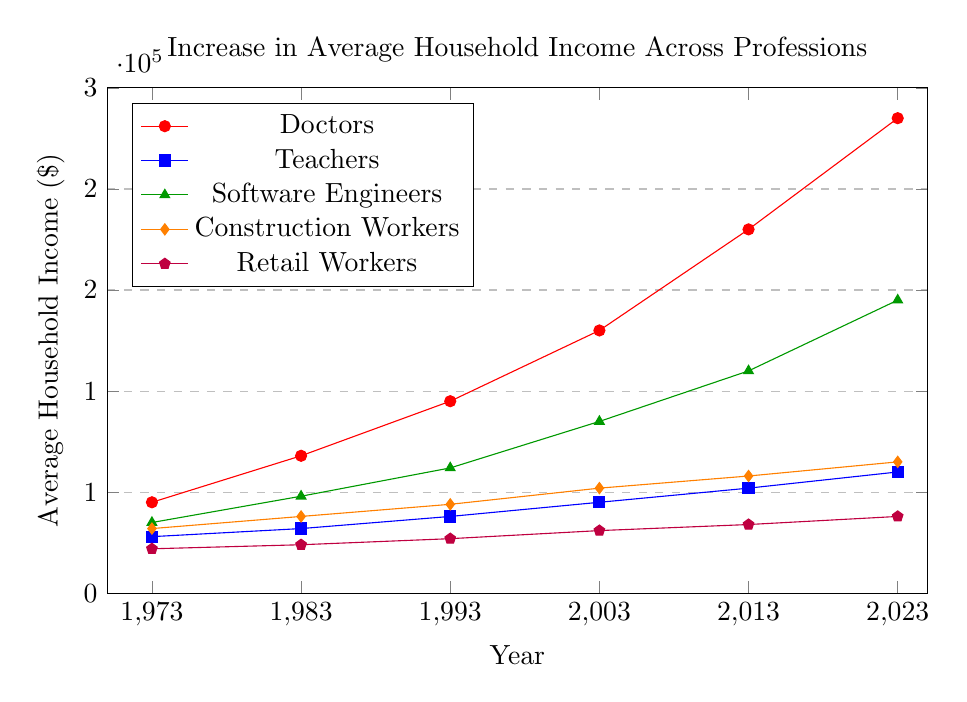What profession had the highest average household income in 2023? Look at the data points corresponding to the year 2023. The line representing Doctors has the highest value at $235,000.
Answer: Doctors What is the gap in average household income between Software Engineers and Retail Workers in 2023? Compare the income for Software Engineers ($145,000) and Retail Workers ($38,000) in 2023. Subtract the Retail Workers' income from Software Engineers' income: 145,000 - 38,000 = $107,000.
Answer: $107,000 Which profession showed the smallest increase in average household income from 1973 to 2023? Calculate the increase for each profession by subtracting the 1973 income from the 2023 income: Doctors (235,000 - 45,000 = 190,000), Teachers (60,000 - 28,000 = 32,000), Software Engineers (145,000 - 35,000 = 110,000), Construction Workers (65,000 - 32,000 = 33,000), Retail Workers (38,000 - 22,000 = 16,000). Retail Workers have the smallest increase of $16,000.
Answer: Retail Workers How much more did Doctors earn compared to Teachers in 1993? Check the 1993 income for Doctors ($95,000) and Teachers ($38,000). Subtract Teachers' income from Doctors' income: 95,000 - 38,000 = $57,000.
Answer: $57,000 Which two professions had the closest average household incomes in 2013? Compare the incomes for each profession in 2013: Doctors ($180,000), Teachers ($52,000), Software Engineers ($110,000), Construction Workers ($58,000), Retail Workers ($34,000). Construction Workers and Teachers have the closest values: 58,000 - 52,000 = $6,000.
Answer: Construction Workers and Teachers What trend is observed for Retail Workers' income over the 50 years? Examine the data for Retail Workers from 1973 to 2023: 22,000 (1973), 24,000 (1983), 27,000 (1993), 31,000 (2003), 34,000 (2013), 38,000 (2023). The income shows a consistent upward trend over the years.
Answer: Consistent upward trend On the graph, which color represents Software Engineers? Identify the line representing the increasing incomes for Software Engineers. The color of this line is green.
Answer: Green What is the average increase in household income for Doctors every 10 years? Calculate the total increase for Doctors from 1973 to 2023 (235,000 - 45,000 = 190,000). There are 5 intervals of 10 years. Divide the total increase by the number of intervals: 190,000 / 5 = $38,000.
Answer: $38,000 Between which years did Construction Workers experience the highest income growth? Check the differences between consecutive years for Construction Workers: 1983-1973 (38,000 - 32,000 = 6,000), 1993-1983 (44,000 - 38,000 = 6,000), 2003-1993 (52,000 - 44,000 = 8,000), 2013-2003 (58,000 - 52,000 = 6,000), 2023-2013 (65,000 - 58,000 = 7,000). The highest growth is between 1993 and 2003 (8,000).
Answer: 1993 to 2003 